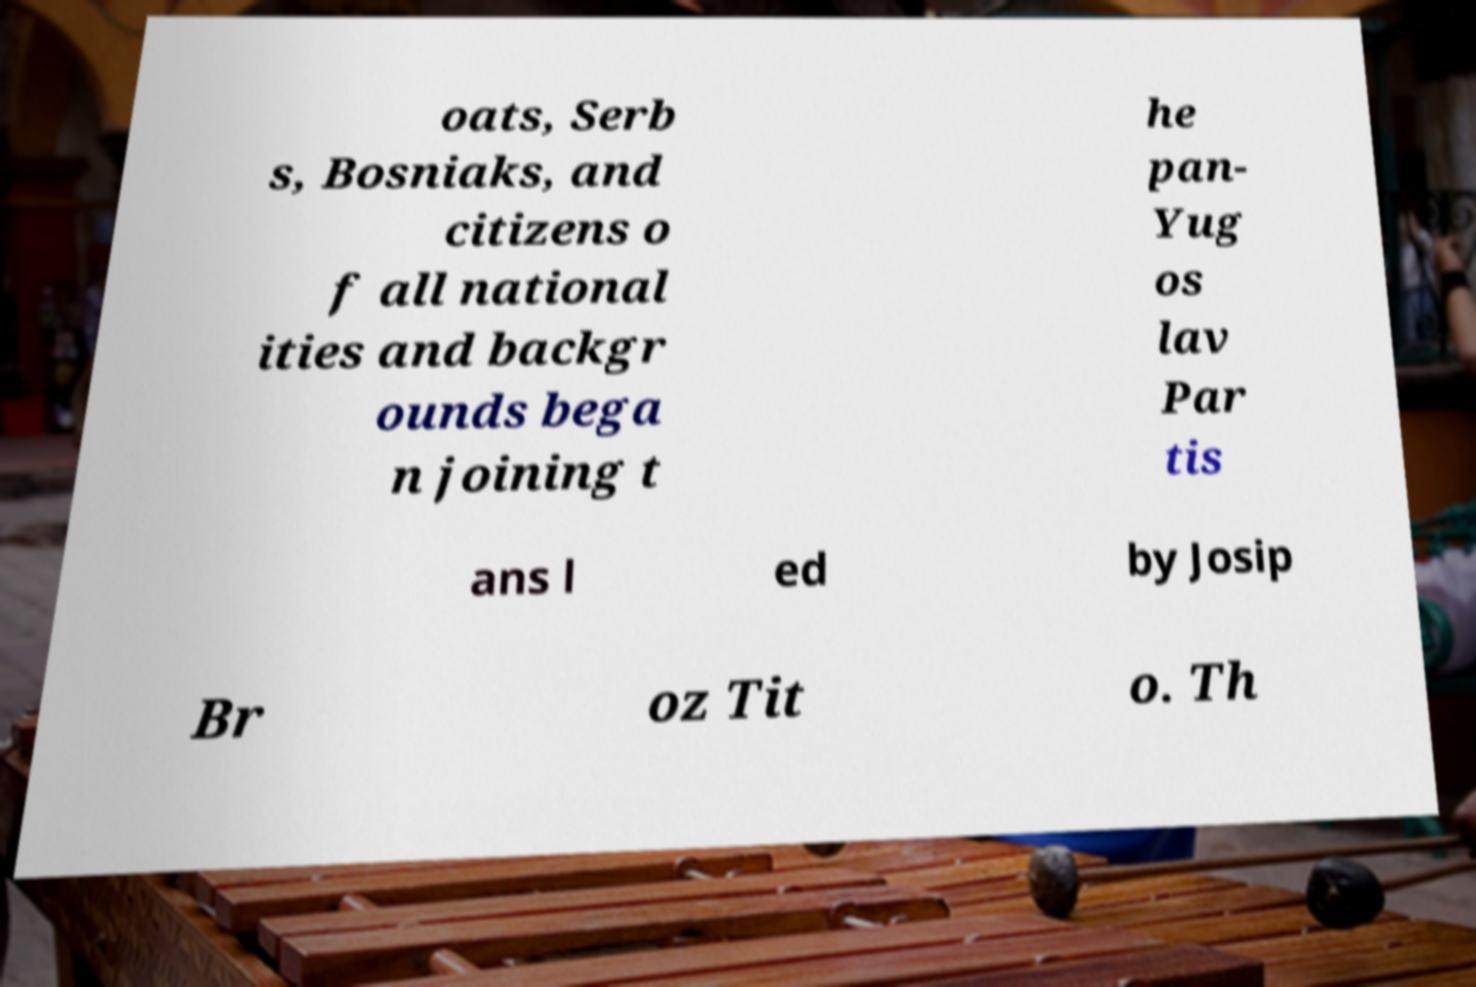Can you accurately transcribe the text from the provided image for me? oats, Serb s, Bosniaks, and citizens o f all national ities and backgr ounds bega n joining t he pan- Yug os lav Par tis ans l ed by Josip Br oz Tit o. Th 